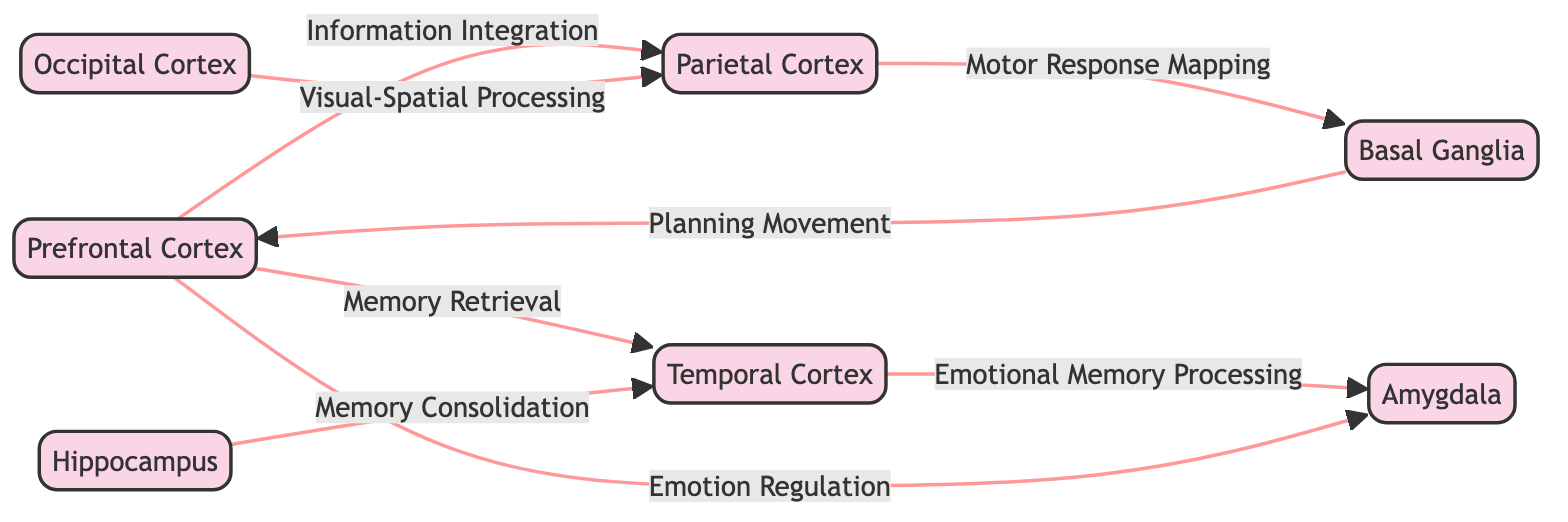What are the functions of the Prefrontal Cortex? The Prefrontal Cortex is associated with two primary functions: Decision Making and Planning. This information is directly available by examining the node details for the Prefrontal Cortex in the diagram.
Answer: Decision Making, Planning How many brain regions are represented in the diagram? The diagram contains a total of seven brain regions, which can be counted by reviewing the nodes listed in the diagram.
Answer: 7 Which brain region is responsible for Visual Processing? Visual Processing is identified as the primary function of the Occipital Cortex, as indicated in the information provided for that specific node.
Answer: Occipital Cortex What is the relationship between the Temporal Cortex and the Amygdala? The relationship between the Temporal Cortex and the Amygdala is characterized as Emotional Memory Processing, as indicated by the connecting edge labeled with this relation in the diagram.
Answer: Emotional Memory Processing Which brain region has a direct connection to both the Prefrontal Cortex and the Hippocampus? The Temporal Cortex has direct connections to both the Prefrontal Cortex (through Memory Retrieval) and the Hippocampus (through Memory Consolidation), as observed from the edges connecting these nodes.
Answer: Temporal Cortex What function is linked to the interaction between the Parietal Cortex and the Basal Ganglia? The interaction between the Parietal Cortex and the Basal Ganglia is described by the relationship of Motor Response Mapping, as seen in the connection labeled in the diagram.
Answer: Motor Response Mapping Which two brain regions interact through the relation of Information Integration? The Prefrontal Cortex interacts with the Parietal Cortex through the relationship of Information Integration, which is explicitly labeled in the diagram between these two nodes.
Answer: Prefrontal Cortex, Parietal Cortex Which brain region is involved in Memory Consolidation? The Hippocampus is responsible for Memory Consolidation as specified in the functions associated with that brain region, directly mentioned in the node details.
Answer: Hippocampus What do the majority of the connections in the diagram represent? The majority of the connections in the diagram can be interpreted as the flow of information processing between regions that support various cognitive functions related to artistic creativity. This is inferred from analyzing all the interactions and their descriptions.
Answer: Information processing 